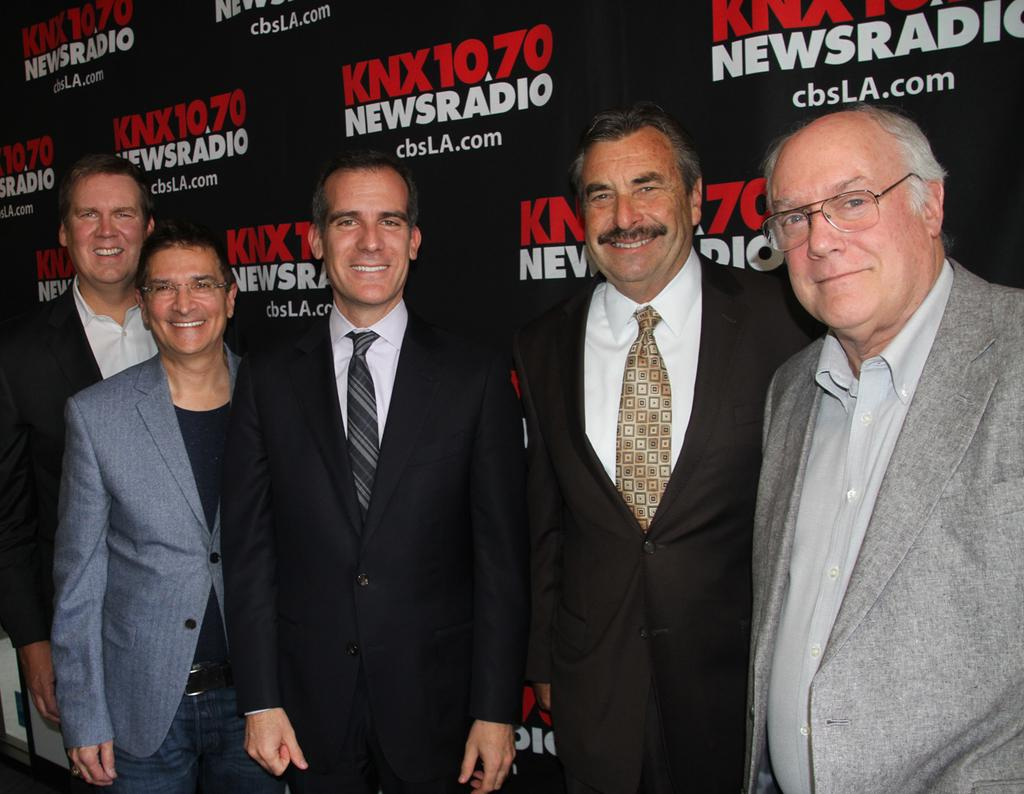How many people are in the foreground of the image? There are five men standing in the foreground of the image. What are the men wearing? The men are wearing suits. What can be seen in the background of the image? There is a black color banner wall in the background of the image. Reasoning: Let' Let's think step by step in order to produce the conversation. We start by identifying the main subjects in the image, which are the five men. Then, we describe what they are wearing, which is suits. Finally, we mention the background element, the black color banner wall. Each question is designed to elicit a specific detail about the image that is known from the provided facts. Absurd Question/Answer: What type of ornament is hanging from the page in the image? There is no page or ornament present in the image. 